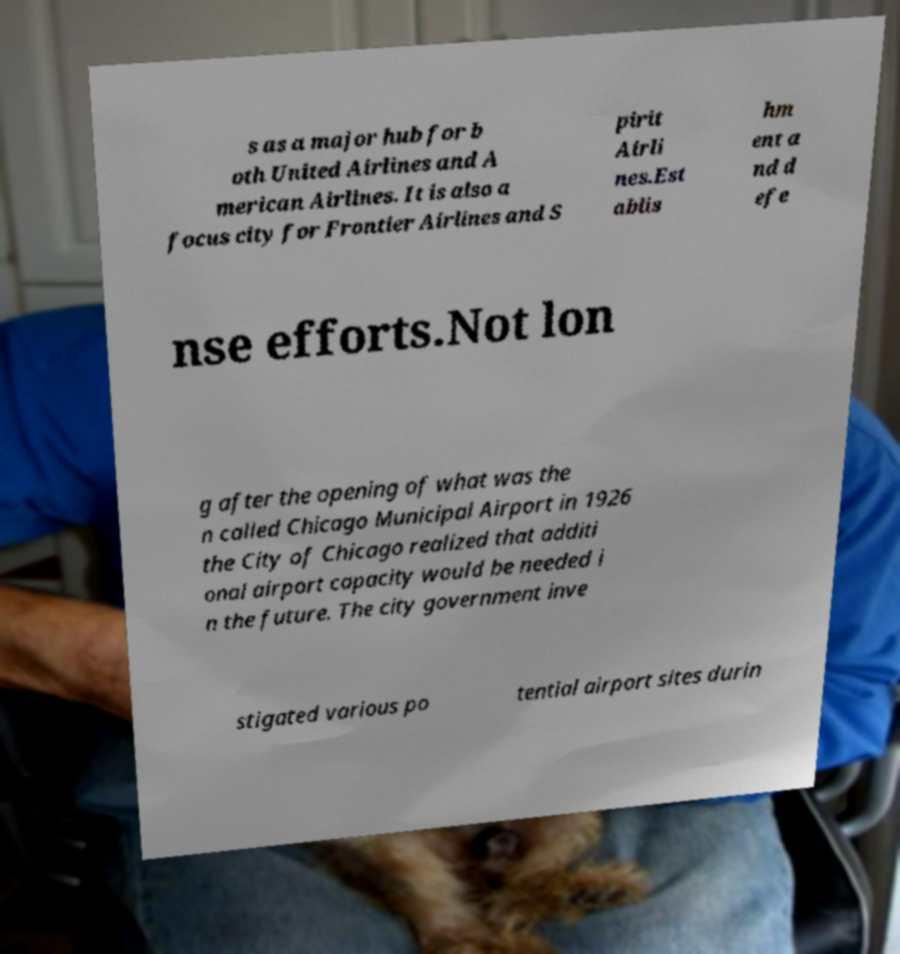Please read and relay the text visible in this image. What does it say? s as a major hub for b oth United Airlines and A merican Airlines. It is also a focus city for Frontier Airlines and S pirit Airli nes.Est ablis hm ent a nd d efe nse efforts.Not lon g after the opening of what was the n called Chicago Municipal Airport in 1926 the City of Chicago realized that additi onal airport capacity would be needed i n the future. The city government inve stigated various po tential airport sites durin 